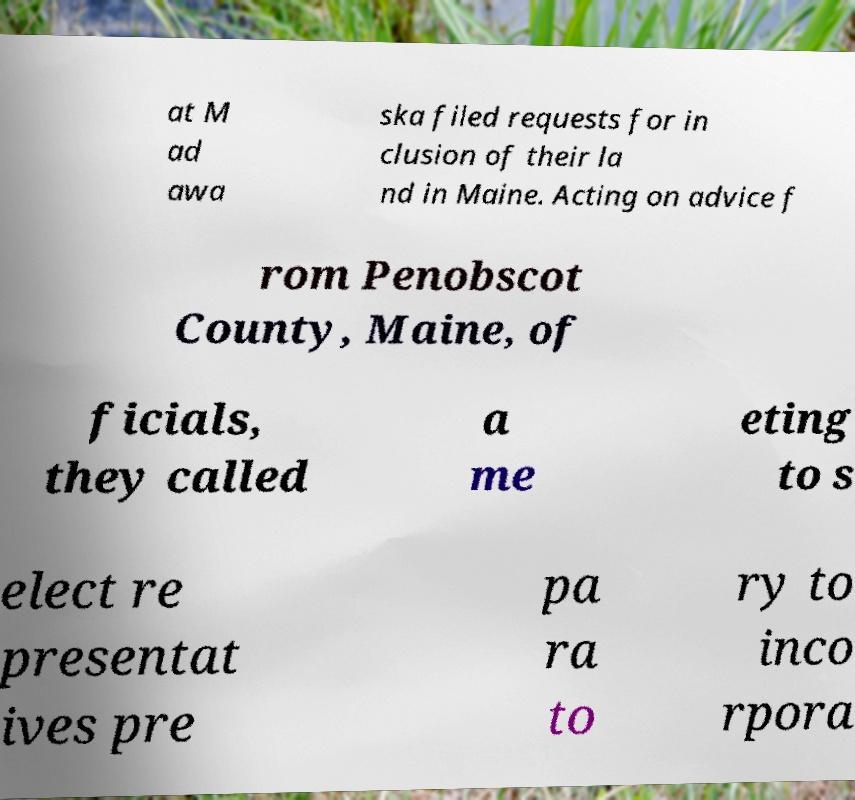What messages or text are displayed in this image? I need them in a readable, typed format. at M ad awa ska filed requests for in clusion of their la nd in Maine. Acting on advice f rom Penobscot County, Maine, of ficials, they called a me eting to s elect re presentat ives pre pa ra to ry to inco rpora 